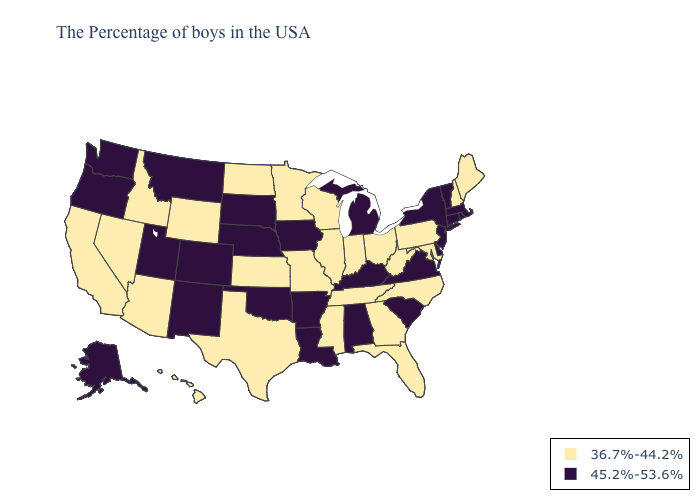Name the states that have a value in the range 45.2%-53.6%?
Quick response, please. Massachusetts, Rhode Island, Vermont, Connecticut, New York, New Jersey, Delaware, Virginia, South Carolina, Michigan, Kentucky, Alabama, Louisiana, Arkansas, Iowa, Nebraska, Oklahoma, South Dakota, Colorado, New Mexico, Utah, Montana, Washington, Oregon, Alaska. Among the states that border California , which have the lowest value?
Quick response, please. Arizona, Nevada. Does the map have missing data?
Keep it brief. No. Does Arkansas have the same value as Missouri?
Be succinct. No. Name the states that have a value in the range 36.7%-44.2%?
Answer briefly. Maine, New Hampshire, Maryland, Pennsylvania, North Carolina, West Virginia, Ohio, Florida, Georgia, Indiana, Tennessee, Wisconsin, Illinois, Mississippi, Missouri, Minnesota, Kansas, Texas, North Dakota, Wyoming, Arizona, Idaho, Nevada, California, Hawaii. Does South Carolina have the highest value in the South?
Short answer required. Yes. What is the lowest value in the USA?
Short answer required. 36.7%-44.2%. Name the states that have a value in the range 45.2%-53.6%?
Answer briefly. Massachusetts, Rhode Island, Vermont, Connecticut, New York, New Jersey, Delaware, Virginia, South Carolina, Michigan, Kentucky, Alabama, Louisiana, Arkansas, Iowa, Nebraska, Oklahoma, South Dakota, Colorado, New Mexico, Utah, Montana, Washington, Oregon, Alaska. What is the value of Michigan?
Give a very brief answer. 45.2%-53.6%. What is the value of Georgia?
Be succinct. 36.7%-44.2%. Name the states that have a value in the range 45.2%-53.6%?
Keep it brief. Massachusetts, Rhode Island, Vermont, Connecticut, New York, New Jersey, Delaware, Virginia, South Carolina, Michigan, Kentucky, Alabama, Louisiana, Arkansas, Iowa, Nebraska, Oklahoma, South Dakota, Colorado, New Mexico, Utah, Montana, Washington, Oregon, Alaska. Among the states that border Oklahoma , which have the highest value?
Keep it brief. Arkansas, Colorado, New Mexico. Is the legend a continuous bar?
Be succinct. No. Which states have the highest value in the USA?
Give a very brief answer. Massachusetts, Rhode Island, Vermont, Connecticut, New York, New Jersey, Delaware, Virginia, South Carolina, Michigan, Kentucky, Alabama, Louisiana, Arkansas, Iowa, Nebraska, Oklahoma, South Dakota, Colorado, New Mexico, Utah, Montana, Washington, Oregon, Alaska. Which states have the lowest value in the West?
Concise answer only. Wyoming, Arizona, Idaho, Nevada, California, Hawaii. 